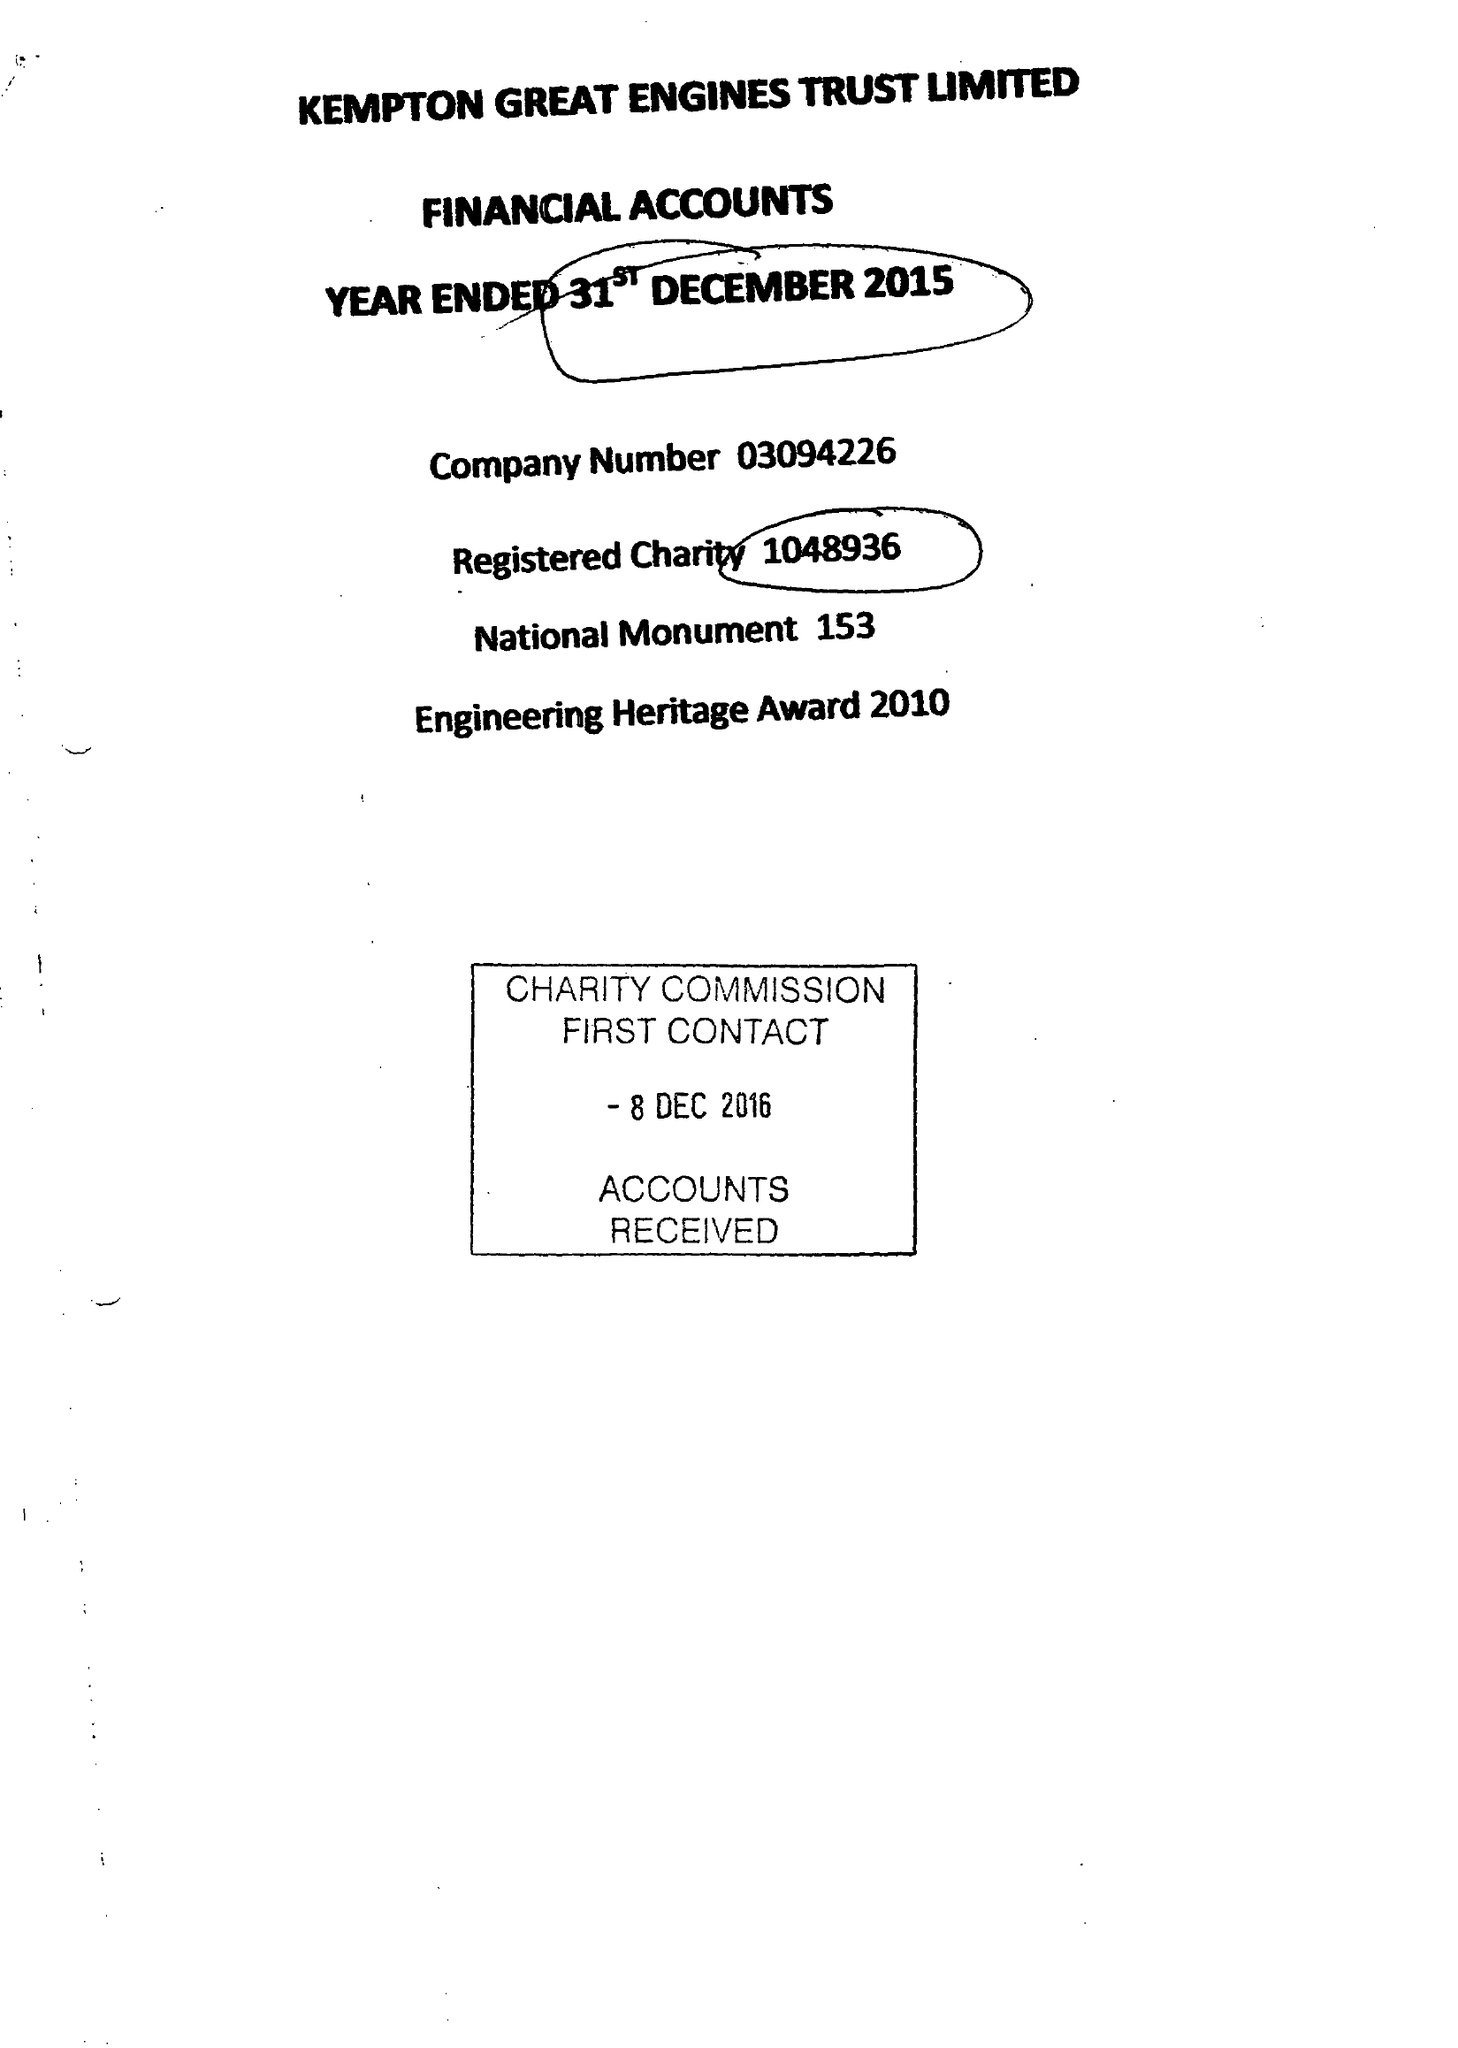What is the value for the charity_name?
Answer the question using a single word or phrase. Kempton Great Engines Trust Ltd. 